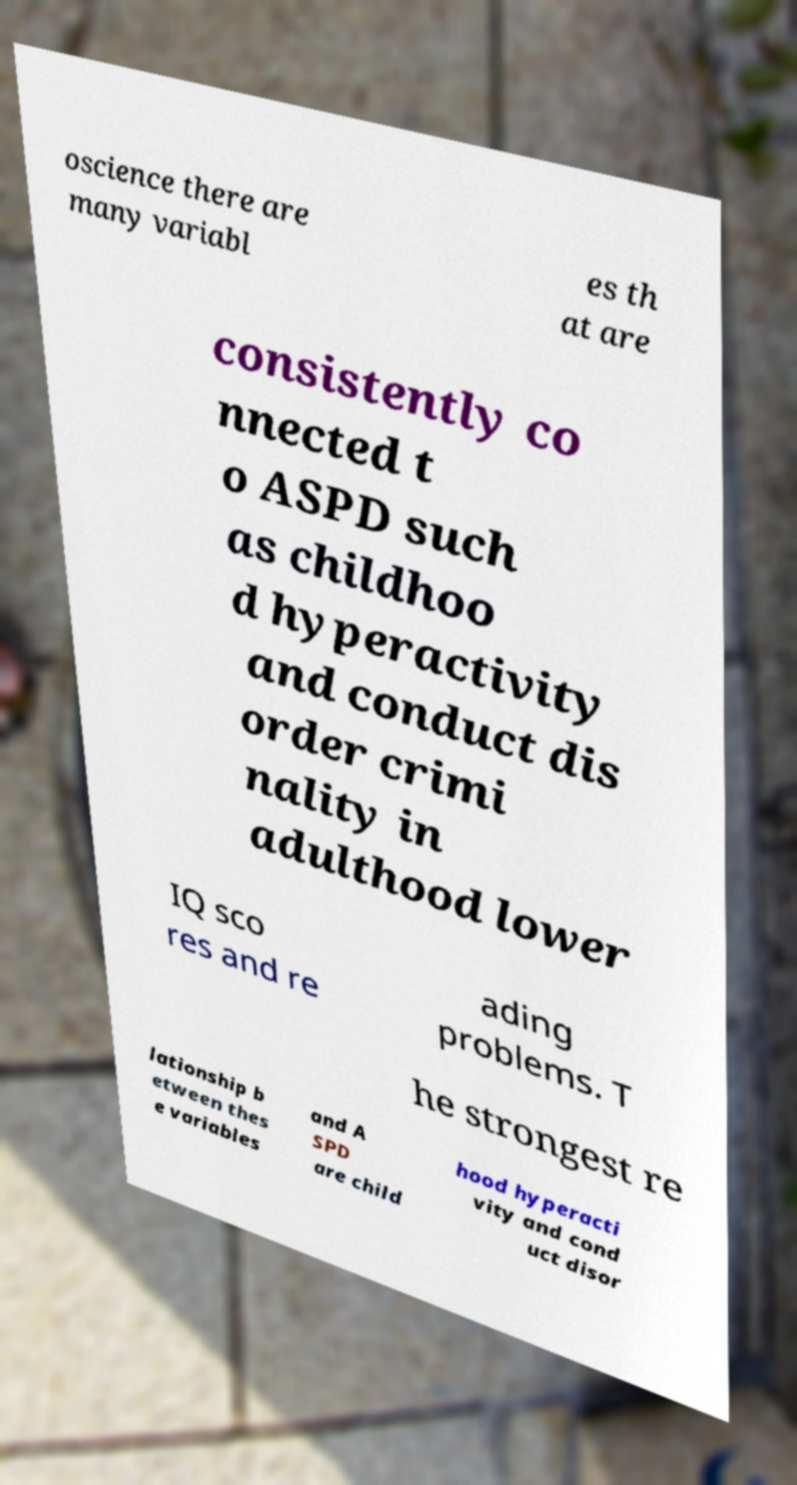There's text embedded in this image that I need extracted. Can you transcribe it verbatim? oscience there are many variabl es th at are consistently co nnected t o ASPD such as childhoo d hyperactivity and conduct dis order crimi nality in adulthood lower IQ sco res and re ading problems. T he strongest re lationship b etween thes e variables and A SPD are child hood hyperacti vity and cond uct disor 